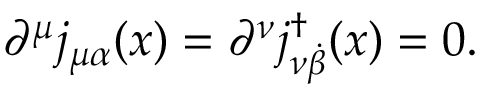<formula> <loc_0><loc_0><loc_500><loc_500>\partial ^ { \mu } j _ { \mu \alpha } ( x ) = \partial ^ { \nu } j _ { \nu { \dot { \beta } } } ^ { \dag } ( x ) = 0 .</formula> 